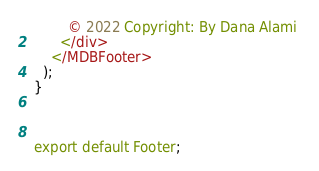Convert code to text. <code><loc_0><loc_0><loc_500><loc_500><_JavaScript_>        © 2022 Copyright: By Dana Alami 
      </div>
    </MDBFooter>
  );
}



export default Footer;</code> 